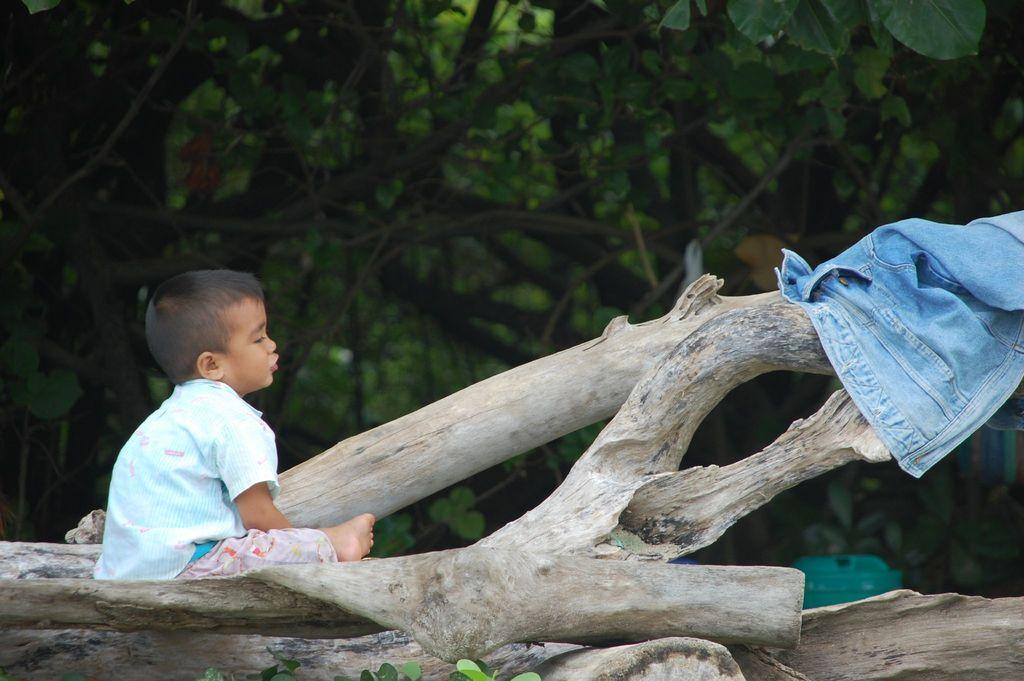What is the boy doing in the image? The boy is sitting on a tree branch in the image. What is on the tree branch with the boy? There is a pair of jeans on the tree branch. What object can be seen in the image for disposing of waste? There is a dustbin in the image. What type of natural vegetation is visible in the image? There are leaves visible in the image. What can be seen in the background of the image? There are trees in the background of the image. What type of cord is the boy using to climb the tree in the image? There is no cord visible in the image, and the boy is sitting on the tree branch, not climbing. 